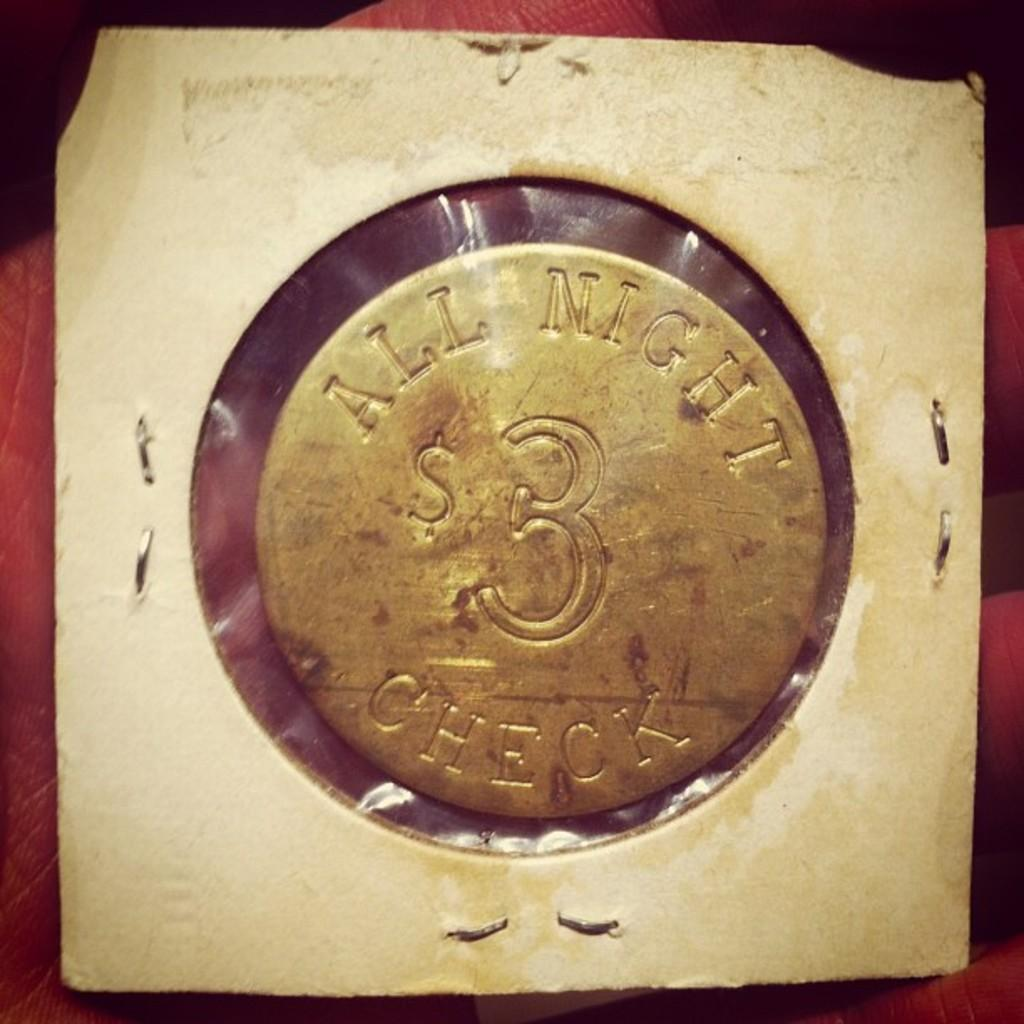<image>
Present a compact description of the photo's key features. A metallic circle has "ALL MIGHT CHECK" engraved into it. 